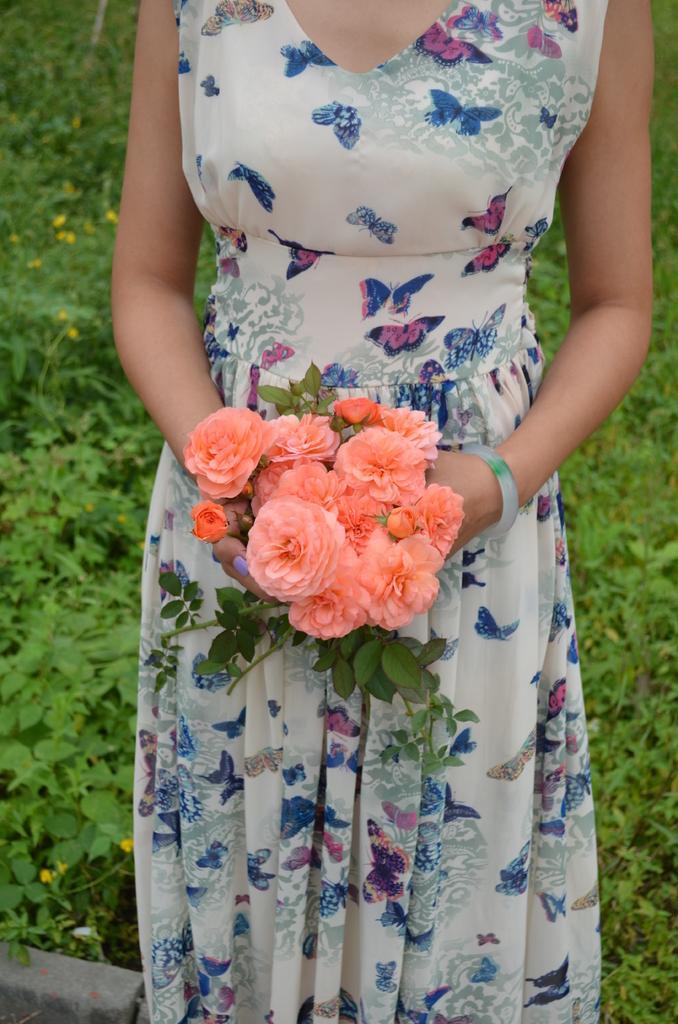Describe this image in one or two sentences. In this image I can see a woman wearing white, blue and pink colored dress is standing and holding few flowers in her hand which are orange in color. In the background I can see few trees which are green in color. 